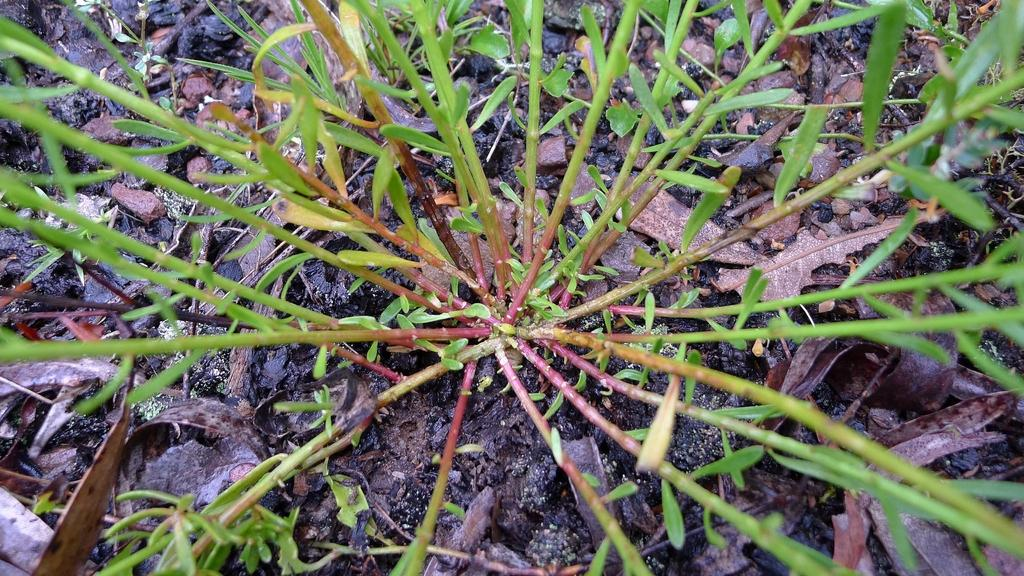What type of living organisms can be seen in the image? Plants can be seen in the image. What can be found on the ground in the image? There are leaves on the ground in the image. What type of stamp can be seen on the leaves in the image? There is no stamp present on the leaves in the image. What emotion can be felt by the plants in the image? Plants do not have emotions, so it is not possible to determine what emotion they might feel. 